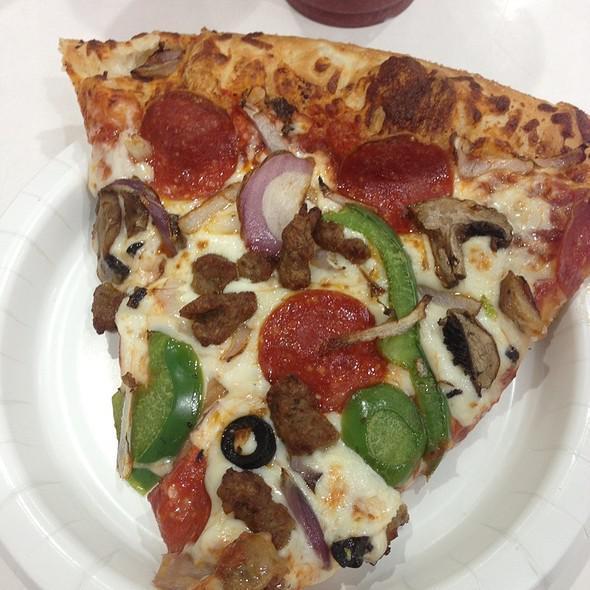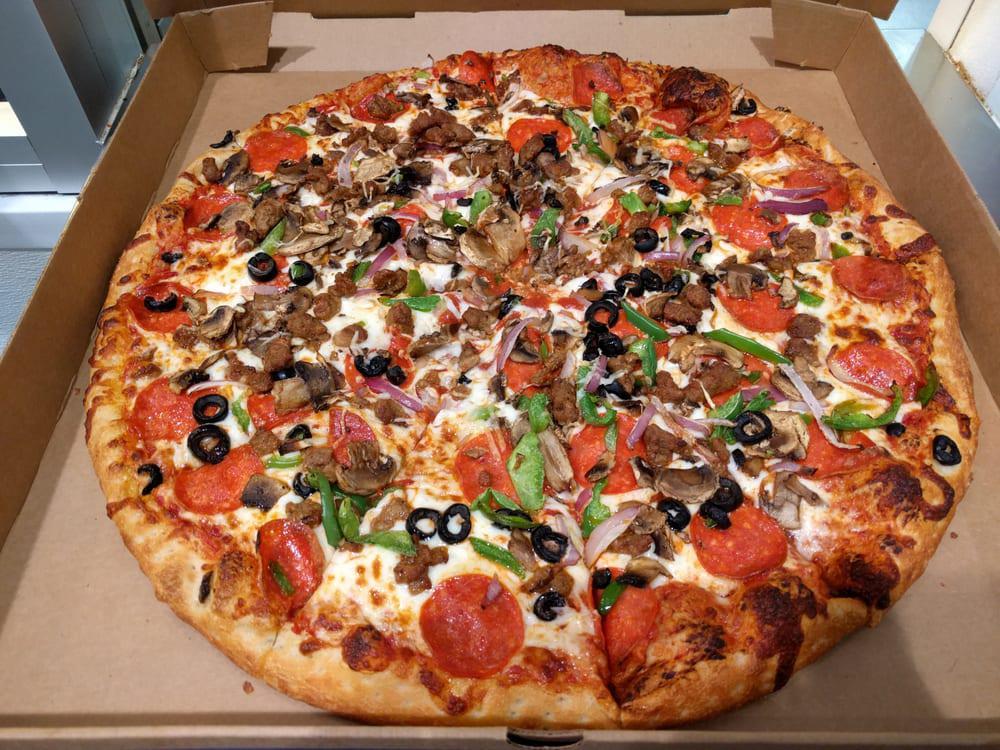The first image is the image on the left, the second image is the image on the right. Assess this claim about the two images: "The right image shows a whole sliced pizza in an open box, and the left image shows a triangular slice of pizza on a small round white plate.". Correct or not? Answer yes or no. Yes. The first image is the image on the left, the second image is the image on the right. Given the left and right images, does the statement "One image shows al least one pizza slice in a disposable plate and the other shows a full pizza in a brown cardboard box." hold true? Answer yes or no. Yes. 